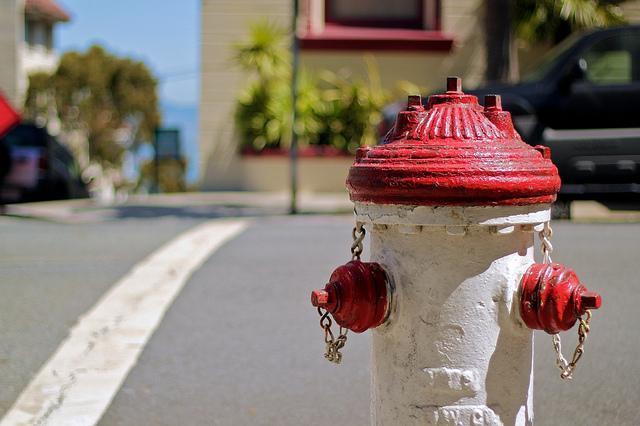How many cars are in the photo?
Give a very brief answer. 2. How many children stand next to the man in the red shirt?
Give a very brief answer. 0. 